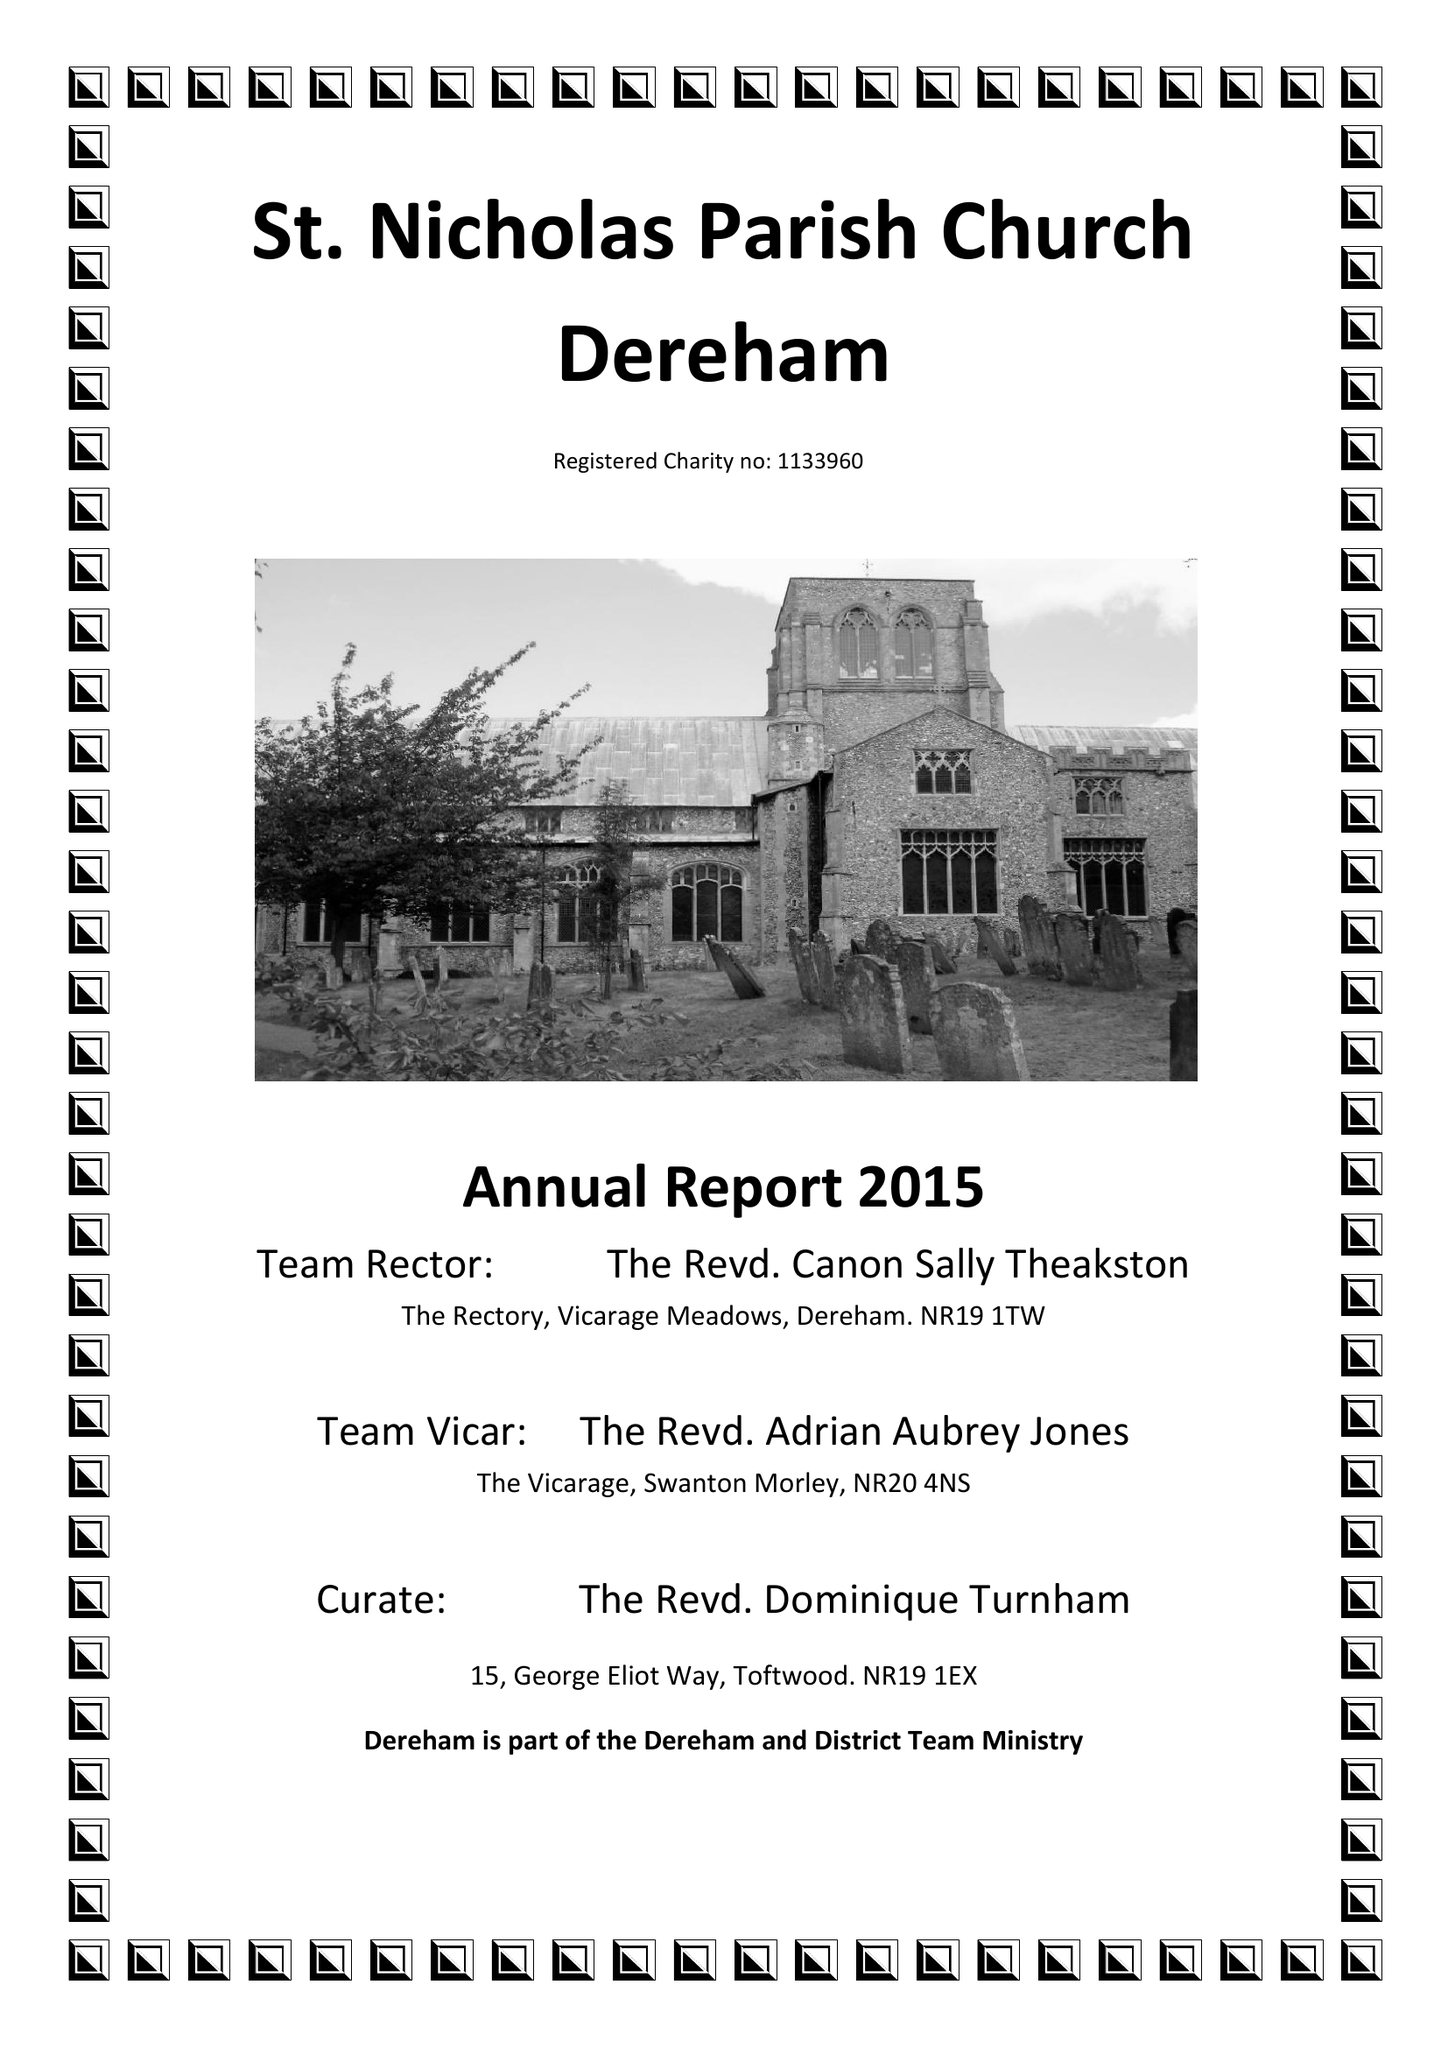What is the value for the address__street_line?
Answer the question using a single word or phrase. CHURCH STREET 